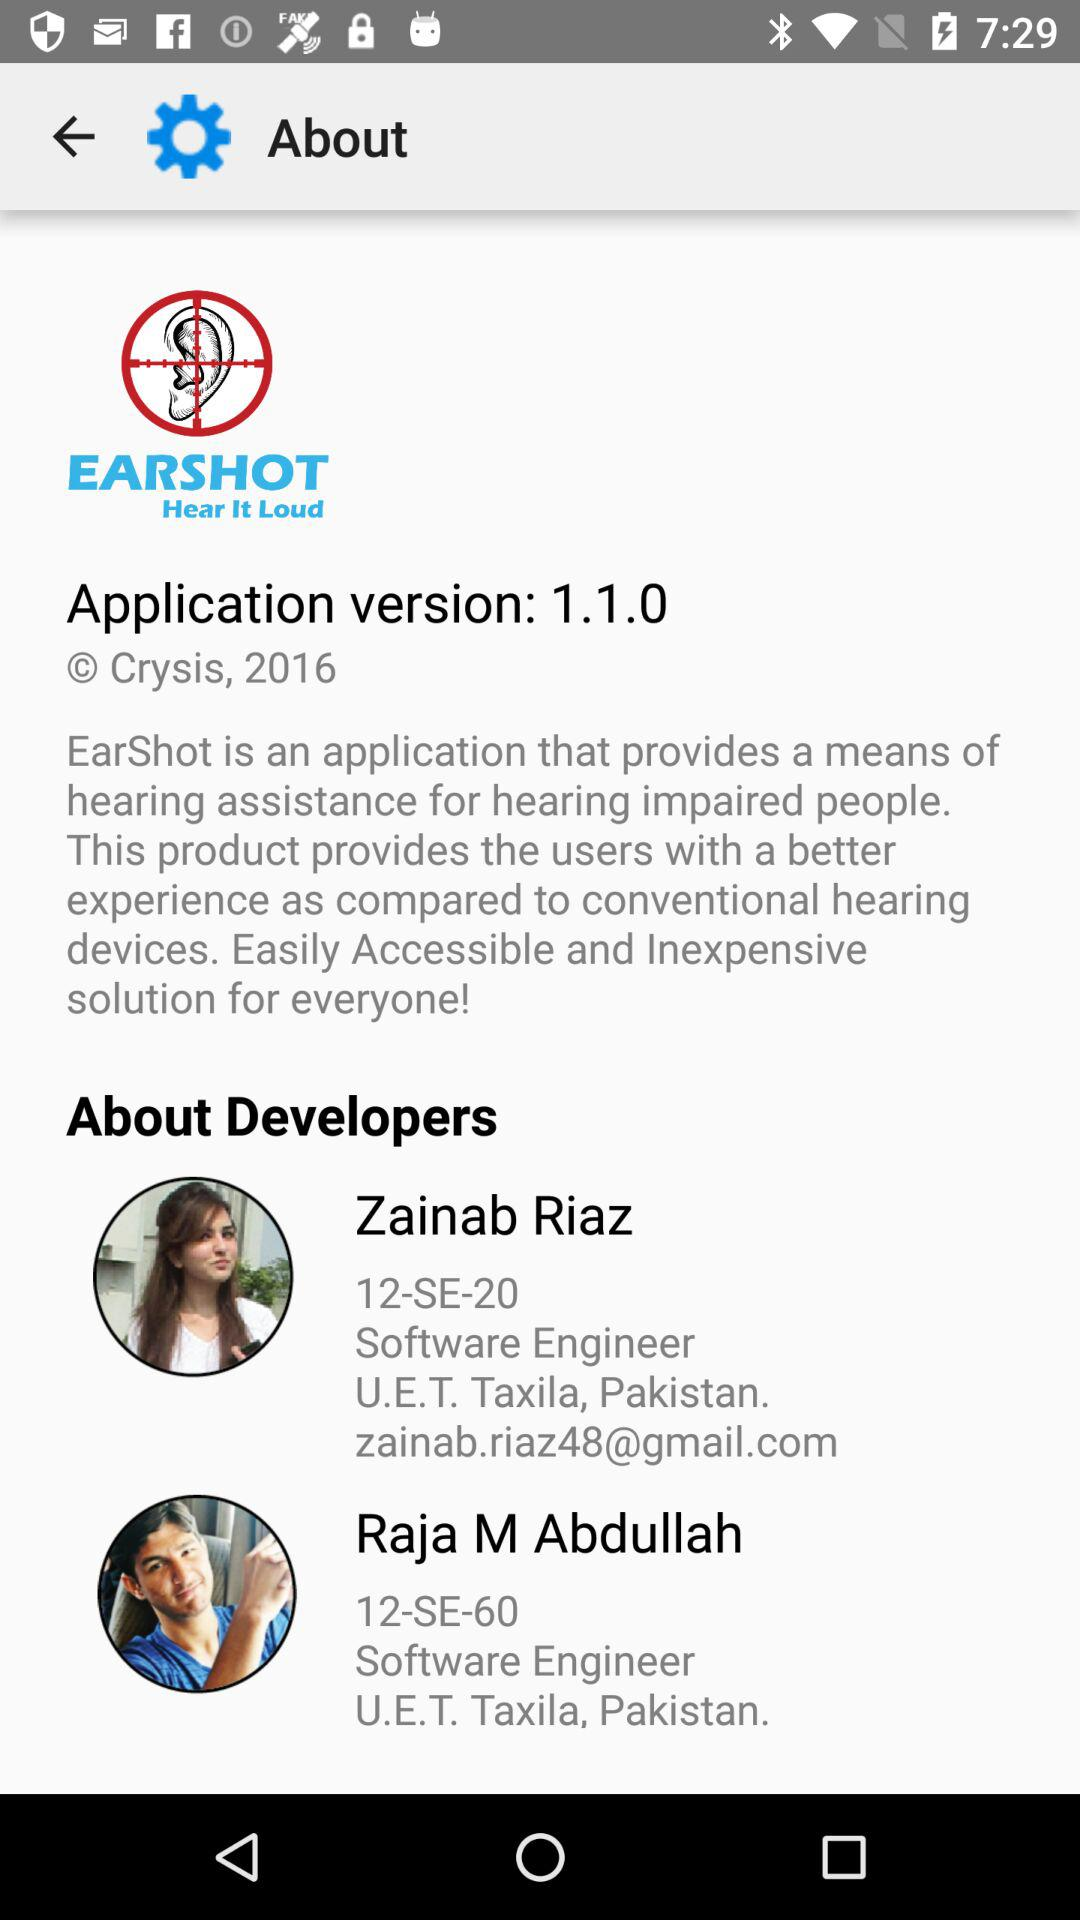Where are the developers located? The developers are located at U.E.T. Taxila, Pakistan. 